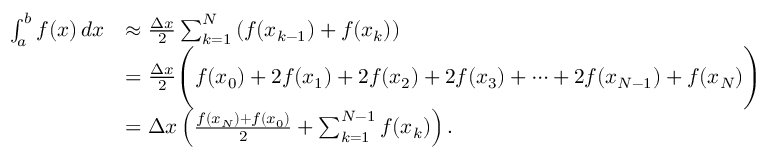<formula> <loc_0><loc_0><loc_500><loc_500>{ \begin{array} { r l } { \int _ { a } ^ { b } f ( x ) \, d x } & { \approx { \frac { \Delta x } { 2 } } \sum _ { k = 1 } ^ { N } \left ( f ( x _ { k - 1 } ) + f ( x _ { k } ) \right ) } \\ & { = { \frac { \Delta x } { 2 } } { \left ( } f ( x _ { 0 } ) + 2 f ( x _ { 1 } ) + 2 f ( x _ { 2 } ) + 2 f ( x _ { 3 } ) + \dots b + 2 f ( x _ { N - 1 } ) + f ( x _ { N } ) { \right ) } } \\ & { = \Delta x \left ( { \frac { f ( x _ { N } ) + f ( x _ { 0 } ) } { 2 } } + \sum _ { k = 1 } ^ { N - 1 } f ( x _ { k } ) \right ) . } \end{array} }</formula> 